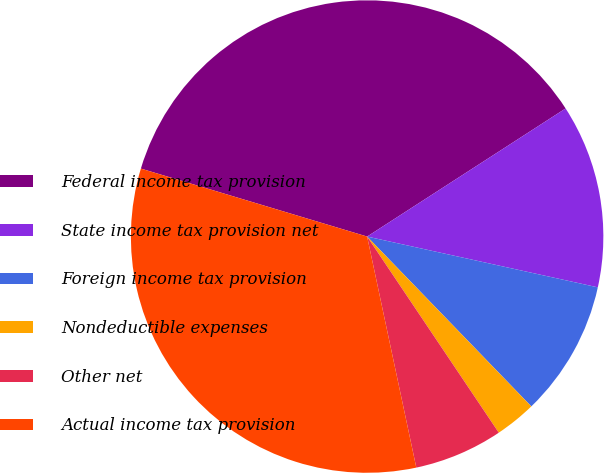<chart> <loc_0><loc_0><loc_500><loc_500><pie_chart><fcel>Federal income tax provision<fcel>State income tax provision net<fcel>Foreign income tax provision<fcel>Nondeductible expenses<fcel>Other net<fcel>Actual income tax provision<nl><fcel>36.23%<fcel>12.57%<fcel>9.32%<fcel>2.82%<fcel>6.07%<fcel>32.98%<nl></chart> 